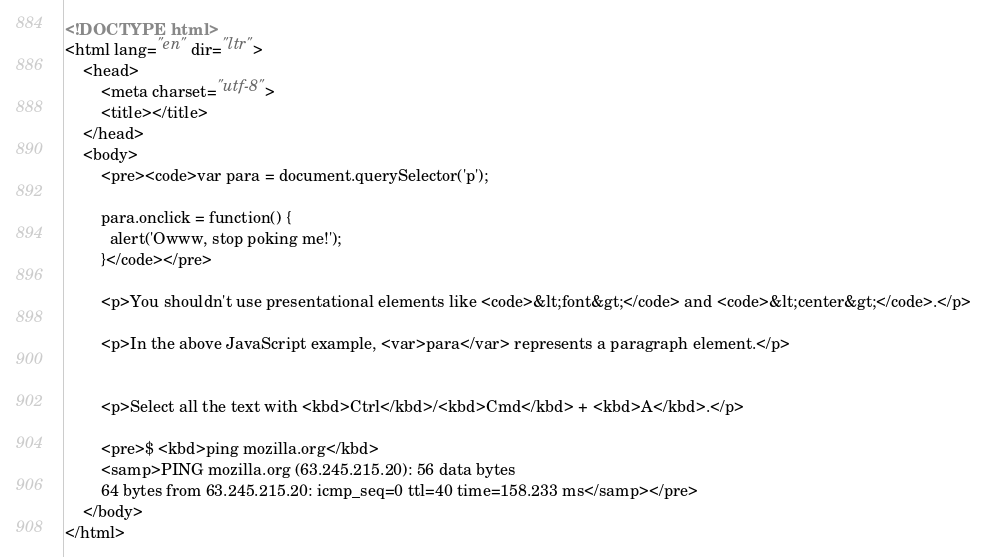<code> <loc_0><loc_0><loc_500><loc_500><_HTML_><!DOCTYPE html>
<html lang="en" dir="ltr">
    <head>
        <meta charset="utf-8">
        <title></title>
    </head>
    <body>
        <pre><code>var para = document.querySelector('p');

        para.onclick = function() {
          alert('Owww, stop poking me!');
        }</code></pre>

        <p>You shouldn't use presentational elements like <code>&lt;font&gt;</code> and <code>&lt;center&gt;</code>.</p>

        <p>In the above JavaScript example, <var>para</var> represents a paragraph element.</p>


        <p>Select all the text with <kbd>Ctrl</kbd>/<kbd>Cmd</kbd> + <kbd>A</kbd>.</p>

        <pre>$ <kbd>ping mozilla.org</kbd>
        <samp>PING mozilla.org (63.245.215.20): 56 data bytes
        64 bytes from 63.245.215.20: icmp_seq=0 ttl=40 time=158.233 ms</samp></pre>
    </body>
</html>
</code> 